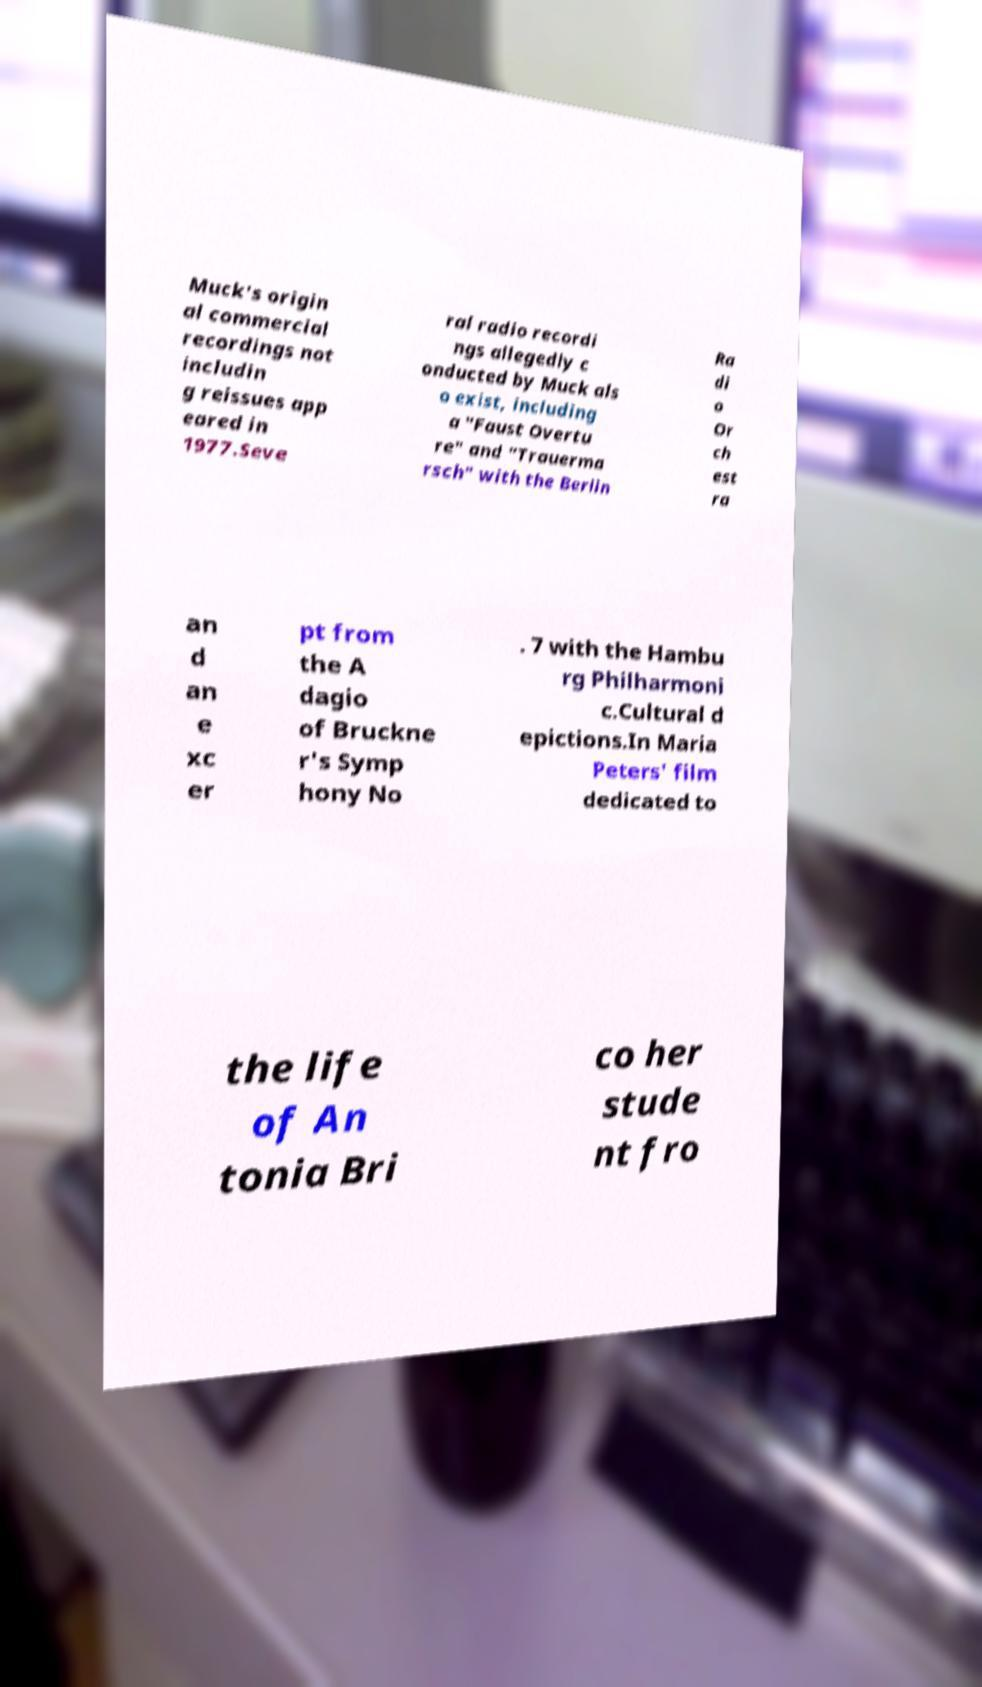Can you read and provide the text displayed in the image?This photo seems to have some interesting text. Can you extract and type it out for me? Muck's origin al commercial recordings not includin g reissues app eared in 1977.Seve ral radio recordi ngs allegedly c onducted by Muck als o exist, including a "Faust Overtu re" and "Trauerma rsch" with the Berlin Ra di o Or ch est ra an d an e xc er pt from the A dagio of Bruckne r's Symp hony No . 7 with the Hambu rg Philharmoni c.Cultural d epictions.In Maria Peters' film dedicated to the life of An tonia Bri co her stude nt fro 